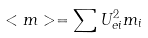Convert formula to latex. <formula><loc_0><loc_0><loc_500><loc_500>< m > = \sum U _ { e i } ^ { 2 } m _ { i }</formula> 